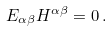<formula> <loc_0><loc_0><loc_500><loc_500>E _ { \alpha \beta } H ^ { \alpha \beta } = 0 \, .</formula> 